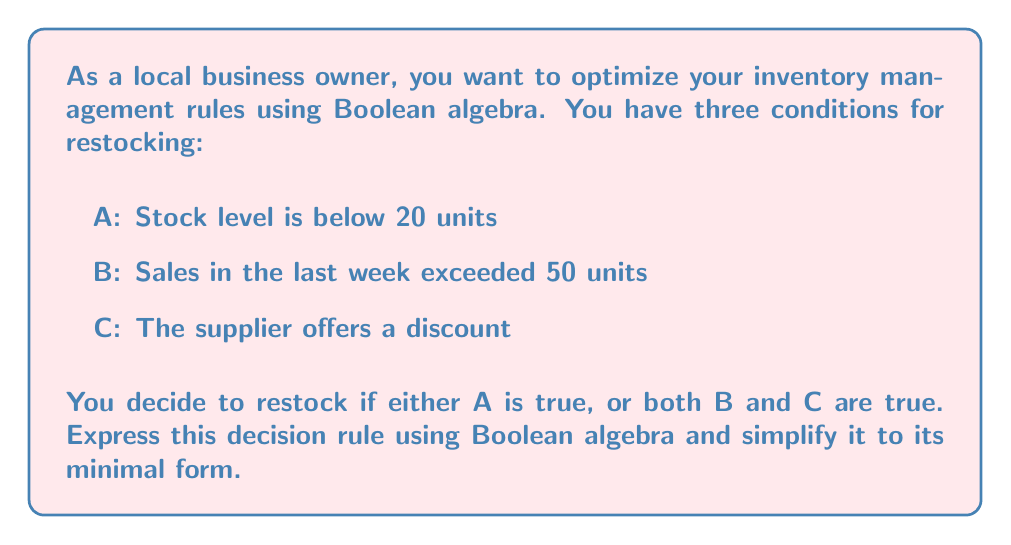Solve this math problem. Let's approach this step-by-step:

1) First, we need to express the given rule in Boolean algebra:
   $$ F = A + (B \cdot C) $$
   Where $F$ represents the decision to restock, $+$ represents OR, and $\cdot$ represents AND.

2) This expression is already in its Sum of Products (SOP) form, but we can check if it can be simplified further using Boolean algebra laws.

3) We can use the distributive law to expand this expression:
   $$ F = A + (B \cdot C) = (A + B) \cdot (A + C) $$

4) Now, let's apply the absorption law: $X + (X \cdot Y) = X$
   In our case, $A + (A \cdot B) = A$ and $A + (A \cdot C) = A$

5) Therefore:
   $$ F = A + (B \cdot C) = (A + B) \cdot (A + C) = A + (B \cdot C) $$

6) We've arrived back at our original expression, which means it was already in its simplest form.

Thus, the minimal form of the decision rule is $A + (B \cdot C)$.
Answer: $A + (B \cdot C)$ 